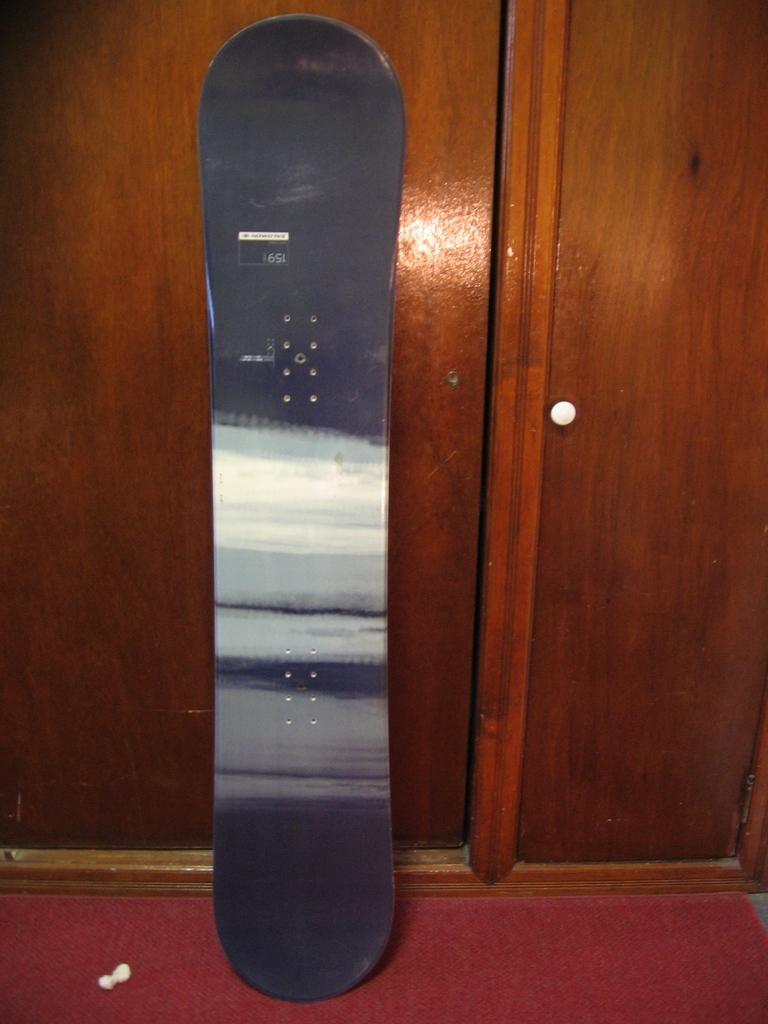What object related to sports or recreation can be seen in the image? There is a skateboard in the image. What type of furniture is present in the image? There is a cupboard in the image. What type of floor covering is visible in the image? There is a red mat in the image. What type of vegetable is being cooked in the stew in the image? There is no stew or vegetable present in the image; it only features a skateboard, a cupboard, and a red mat. 